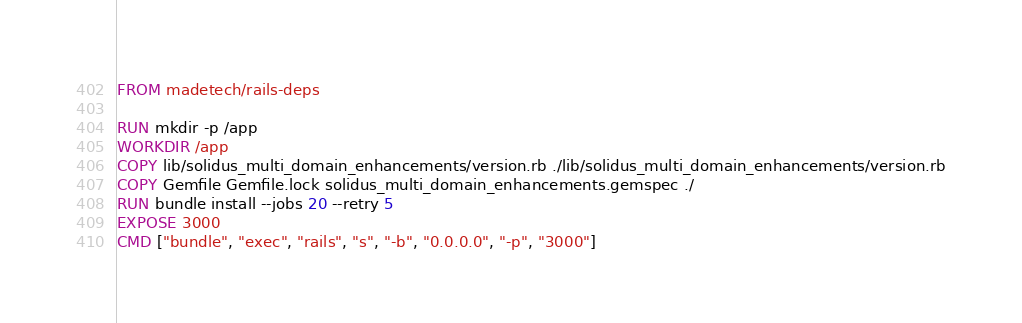Convert code to text. <code><loc_0><loc_0><loc_500><loc_500><_Dockerfile_>FROM madetech/rails-deps

RUN mkdir -p /app
WORKDIR /app
COPY lib/solidus_multi_domain_enhancements/version.rb ./lib/solidus_multi_domain_enhancements/version.rb
COPY Gemfile Gemfile.lock solidus_multi_domain_enhancements.gemspec ./
RUN bundle install --jobs 20 --retry 5
EXPOSE 3000
CMD ["bundle", "exec", "rails", "s", "-b", "0.0.0.0", "-p", "3000"]
</code> 